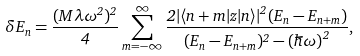Convert formula to latex. <formula><loc_0><loc_0><loc_500><loc_500>\delta E _ { n } = \frac { ( M \lambda \omega ^ { 2 } ) ^ { 2 } } { 4 } \sum _ { m = - \infty } ^ { \infty } \frac { 2 | \langle n + m | z | n \rangle | ^ { 2 } ( E _ { n } - E _ { n + m } ) } { ( E _ { n } - E _ { n + m } ) ^ { 2 } - { ( \hbar { \omega } ) } ^ { 2 } } ,</formula> 